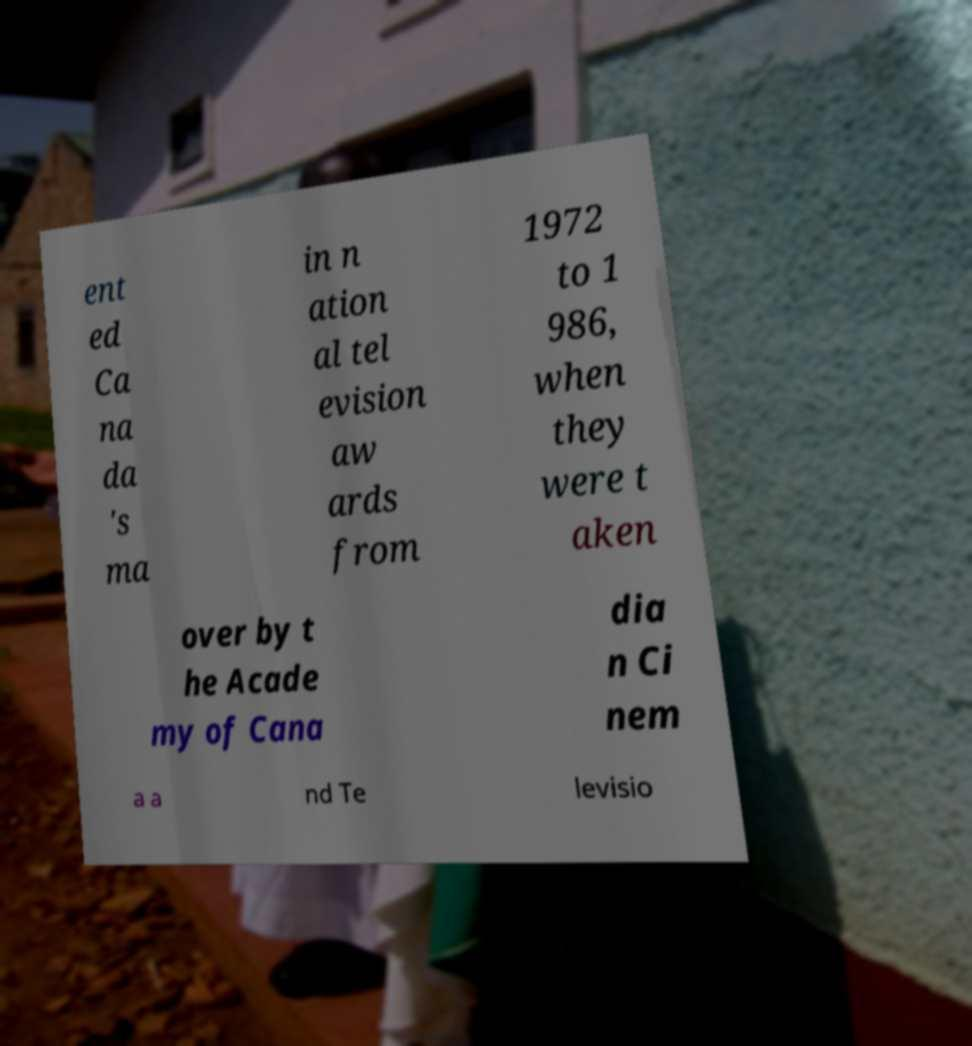What messages or text are displayed in this image? I need them in a readable, typed format. ent ed Ca na da 's ma in n ation al tel evision aw ards from 1972 to 1 986, when they were t aken over by t he Acade my of Cana dia n Ci nem a a nd Te levisio 